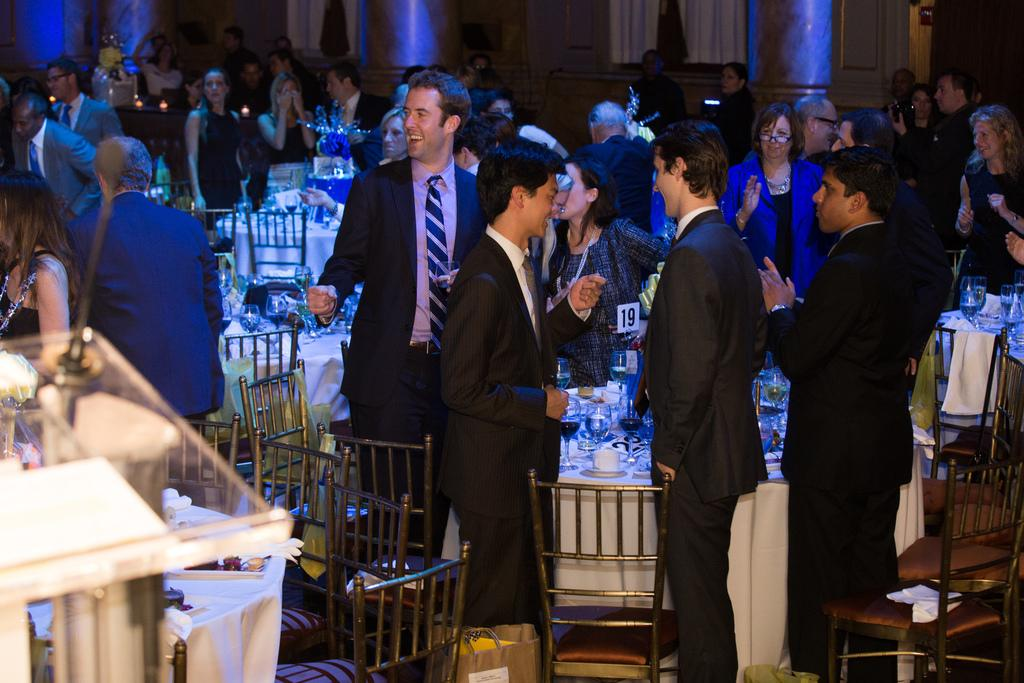What is happening in the image? There are people standing in the image. What is present on the table in the image? There is a table in the image with wine glasses, a jug, and food items on a plate. What might be contained in the jug? The jug could contain a beverage, such as water or juice. What type of food items can be seen on the plate? The specific food items cannot be determined from the image, but there are food items present on the plate. What type of lumber is being used to build the sand castle in the image? There is no sand castle present in the image, and therefore no lumber can be observed. Can you tell me the name of the dad in the image? There is no mention of a dad or any specific individuals in the image, so their names cannot be determined. 